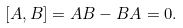Convert formula to latex. <formula><loc_0><loc_0><loc_500><loc_500>[ A , B ] = A B - B A = 0 .</formula> 